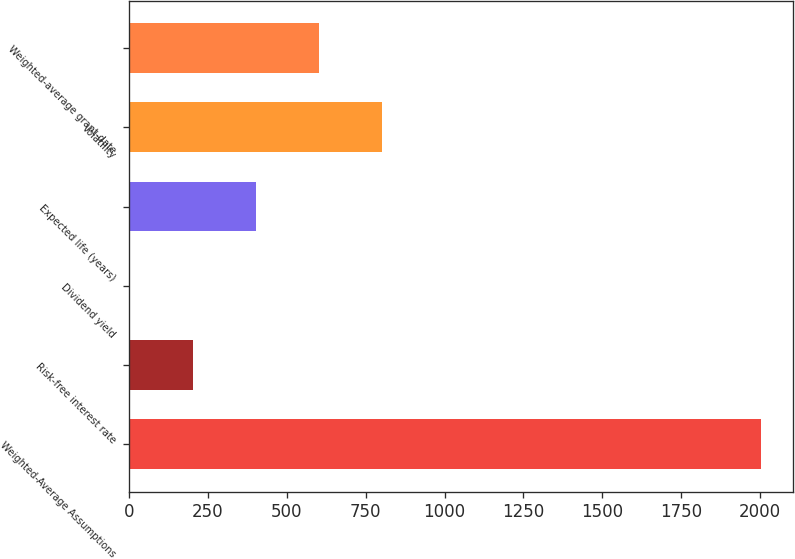Convert chart to OTSL. <chart><loc_0><loc_0><loc_500><loc_500><bar_chart><fcel>Weighted-Average Assumptions<fcel>Risk-free interest rate<fcel>Dividend yield<fcel>Expected life (years)<fcel>Volatility<fcel>Weighted-average grant-date<nl><fcel>2004<fcel>201.93<fcel>1.7<fcel>402.16<fcel>802.62<fcel>602.39<nl></chart> 